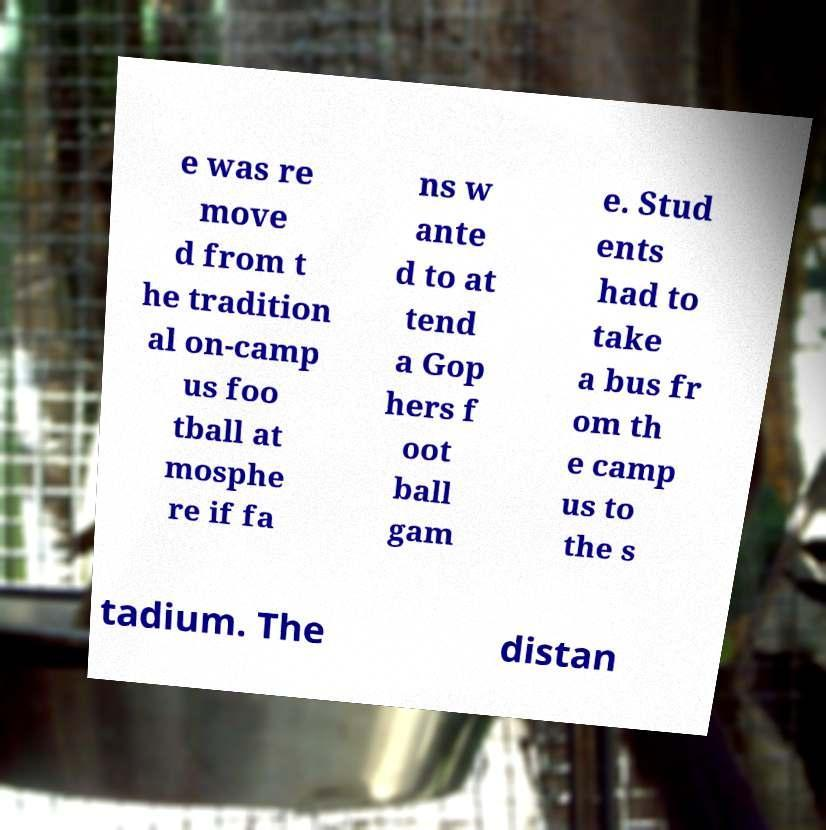Could you assist in decoding the text presented in this image and type it out clearly? e was re move d from t he tradition al on-camp us foo tball at mosphe re if fa ns w ante d to at tend a Gop hers f oot ball gam e. Stud ents had to take a bus fr om th e camp us to the s tadium. The distan 